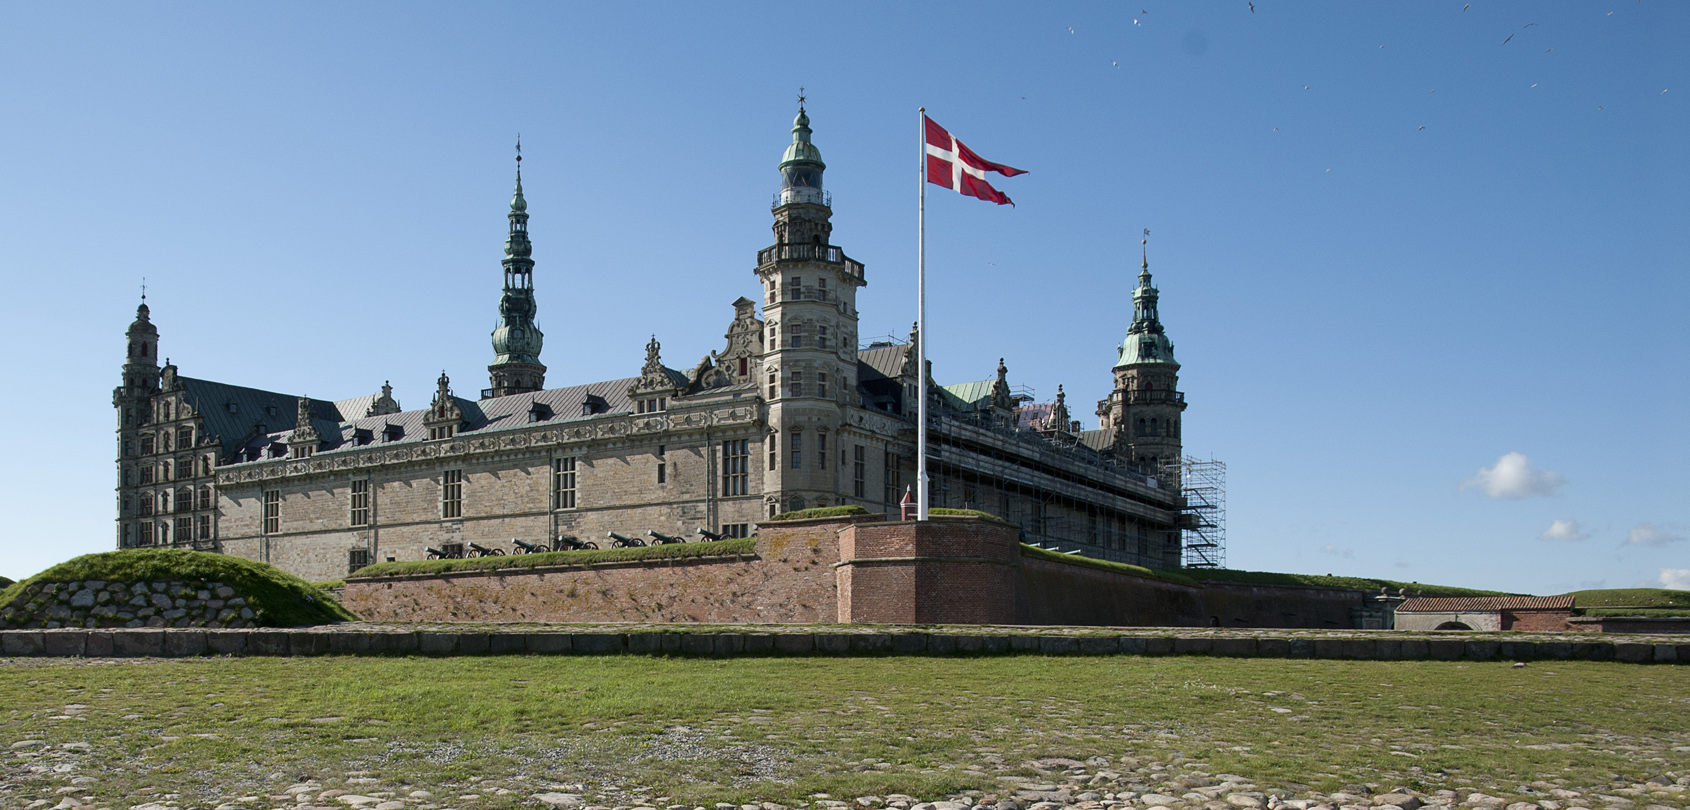What historical events is the Kronborg Castle known for? Kronborg Castle is famed not only as the setting for Shakespeare's Hamlet but also for its significant role in the history of Northern Europe. It was a key fortress controlling the entrance to the Baltic Sea, and from the 16th to the 18th century, it collected tolls from passing ships. It also served as an important royal residence and was the site of numerous historical events, including engagements in the Northern Wars. 